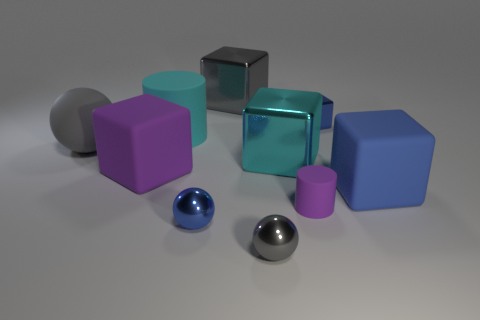Subtract all green cubes. Subtract all red cylinders. How many cubes are left? 5 Subtract all balls. How many objects are left? 7 Subtract 1 gray spheres. How many objects are left? 9 Subtract all large purple cubes. Subtract all large gray spheres. How many objects are left? 8 Add 3 small gray shiny balls. How many small gray shiny balls are left? 4 Add 9 tiny purple rubber cylinders. How many tiny purple rubber cylinders exist? 10 